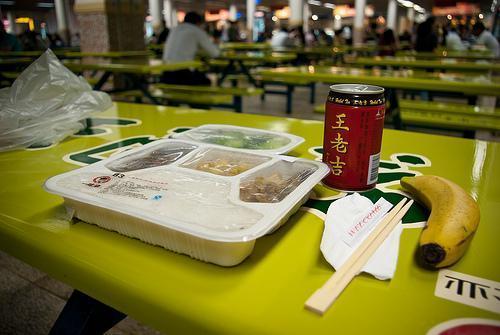How many chopsticks?
Give a very brief answer. 2. 